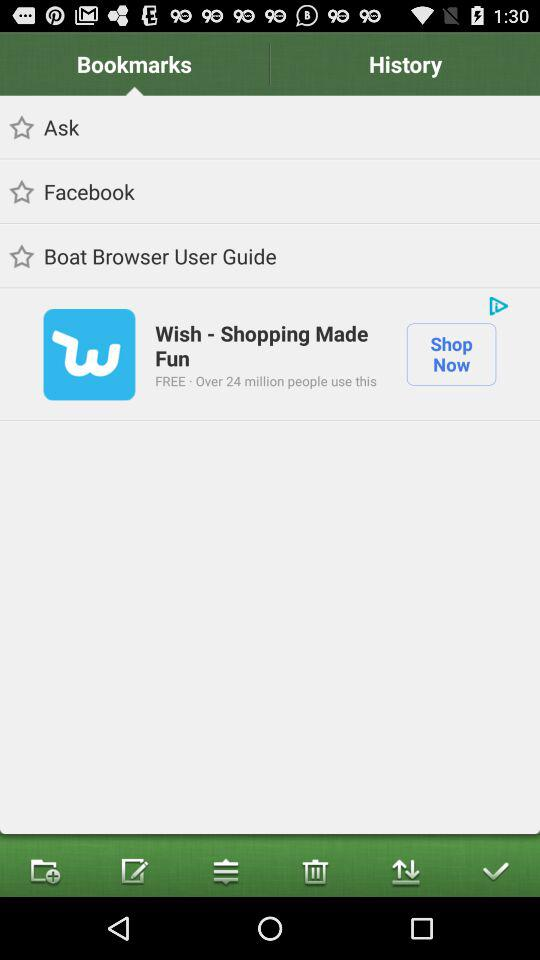Which tab is selected? The selected tab is "Bookmarks". 